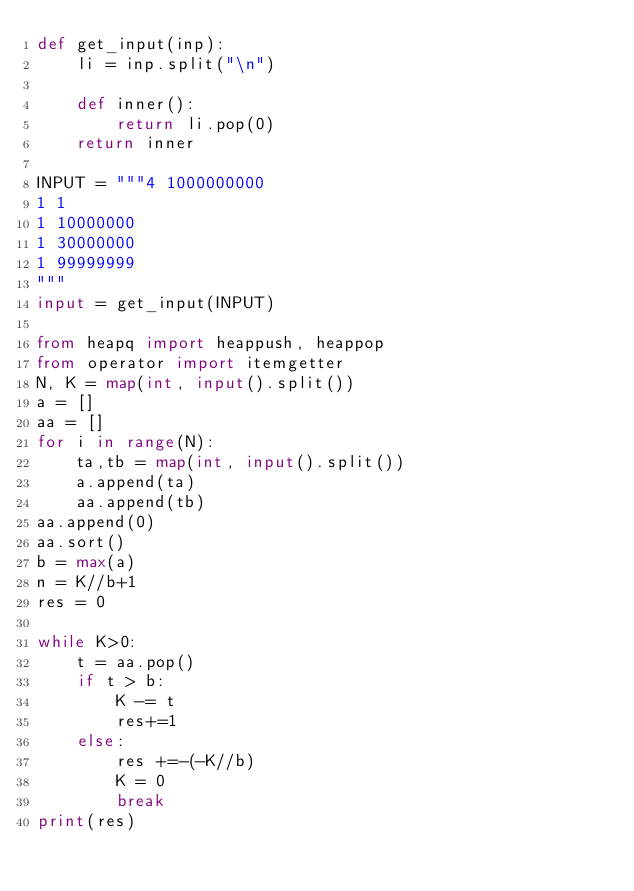<code> <loc_0><loc_0><loc_500><loc_500><_Python_>def get_input(inp):
    li = inp.split("\n")

    def inner():
        return li.pop(0)
    return inner

INPUT = """4 1000000000
1 1
1 10000000
1 30000000
1 99999999
"""
input = get_input(INPUT)

from heapq import heappush, heappop
from operator import itemgetter
N, K = map(int, input().split())
a = []
aa = []
for i in range(N):
    ta,tb = map(int, input().split())
    a.append(ta)
    aa.append(tb)
aa.append(0)
aa.sort()
b = max(a)
n = K//b+1
res = 0

while K>0:
    t = aa.pop()
    if t > b:
        K -= t
        res+=1
    else:
        res +=-(-K//b)
        K = 0
        break
print(res)</code> 